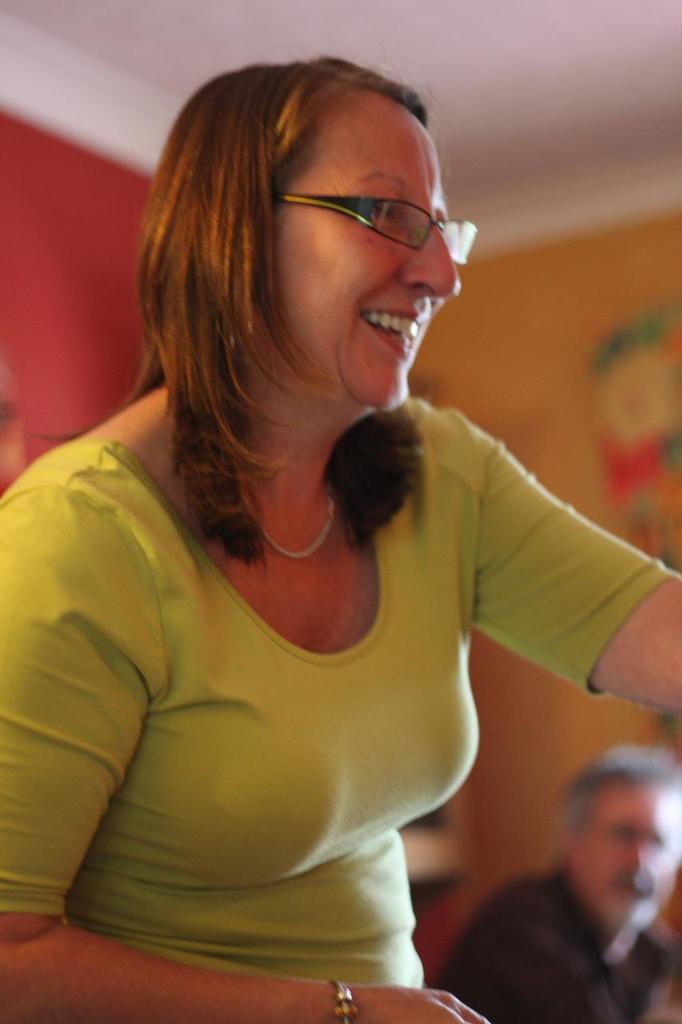Could you give a brief overview of what you see in this image? In this picture I can observe a woman. She is wearing green color T shirt and spectacles. This woman is smiling. On the right side there is another person. In the background I can observe red and yellow color walls. 